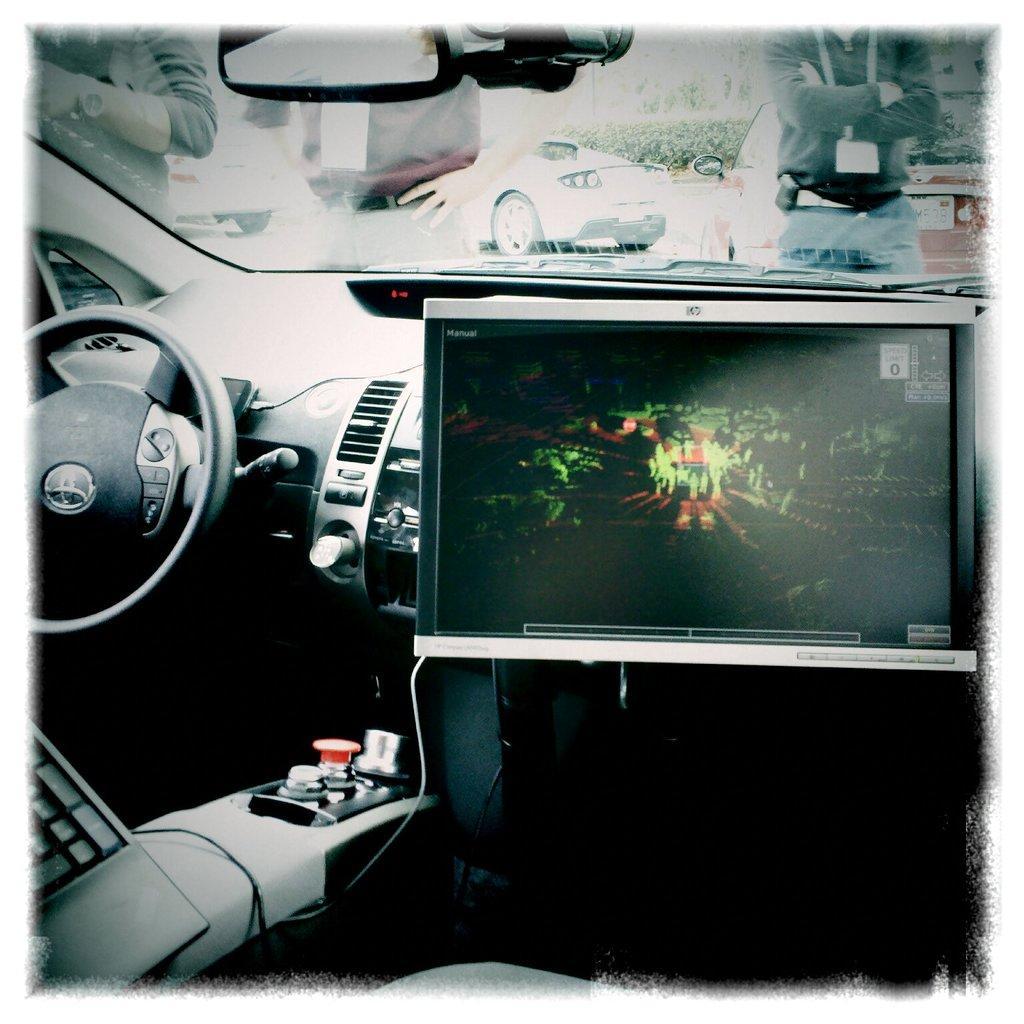In one or two sentences, can you explain what this image depicts? This picture is clicked inside the car. In this picture, we see the steering wheel and dashboard. On the right side, we see a computer screen. Here, we see the front glass from which we can see three men are standing. We even see cars which are moving on the road. In the background, there are trees. 